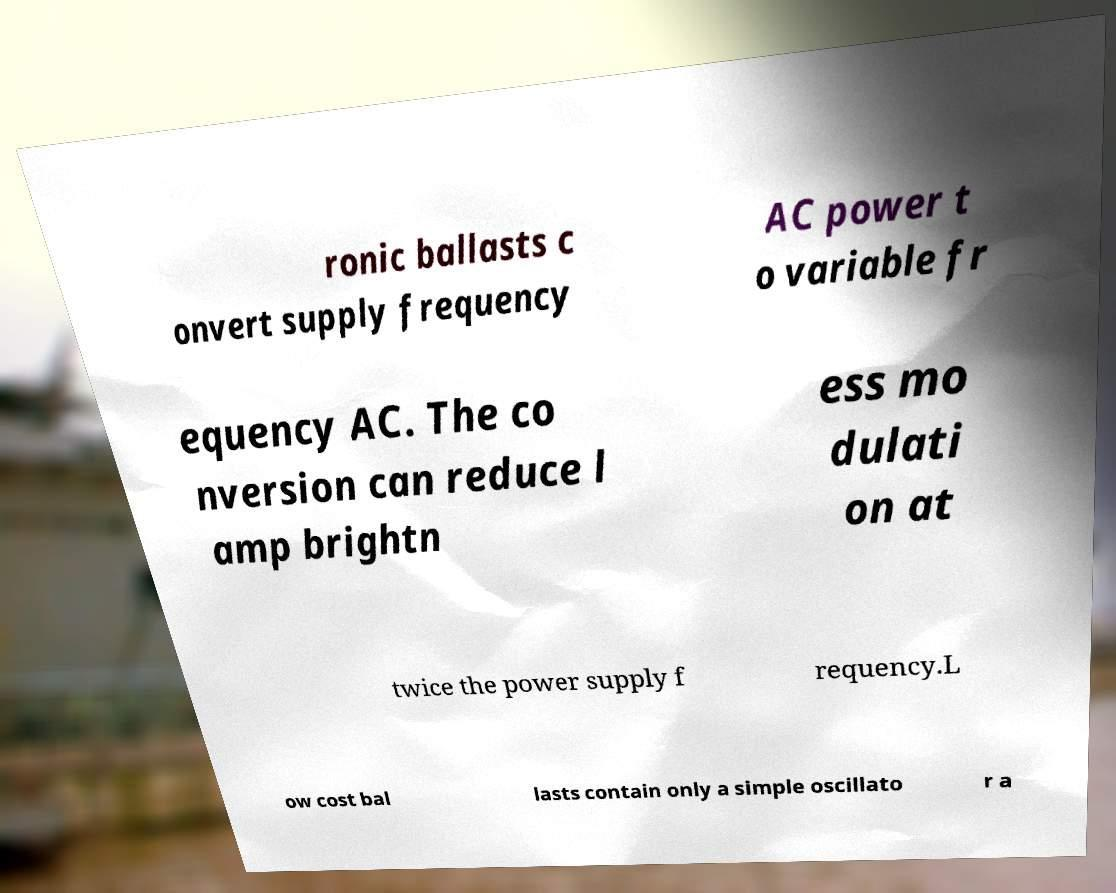For documentation purposes, I need the text within this image transcribed. Could you provide that? ronic ballasts c onvert supply frequency AC power t o variable fr equency AC. The co nversion can reduce l amp brightn ess mo dulati on at twice the power supply f requency.L ow cost bal lasts contain only a simple oscillato r a 